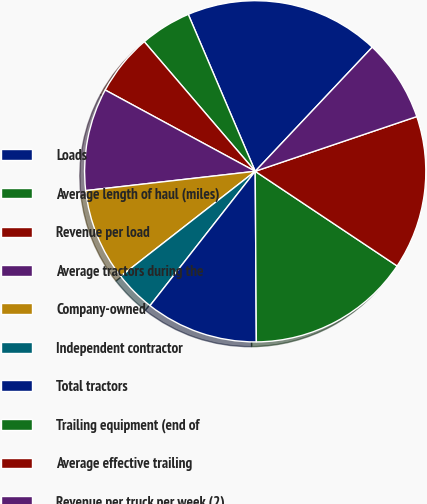Convert chart. <chart><loc_0><loc_0><loc_500><loc_500><pie_chart><fcel>Loads<fcel>Average length of haul (miles)<fcel>Revenue per load<fcel>Average tractors during the<fcel>Company-owned<fcel>Independent contractor<fcel>Total tractors<fcel>Trailing equipment (end of<fcel>Average effective trailing<fcel>Revenue per truck per week (2)<nl><fcel>18.45%<fcel>4.85%<fcel>5.83%<fcel>9.71%<fcel>8.74%<fcel>3.88%<fcel>10.68%<fcel>15.53%<fcel>14.56%<fcel>7.77%<nl></chart> 